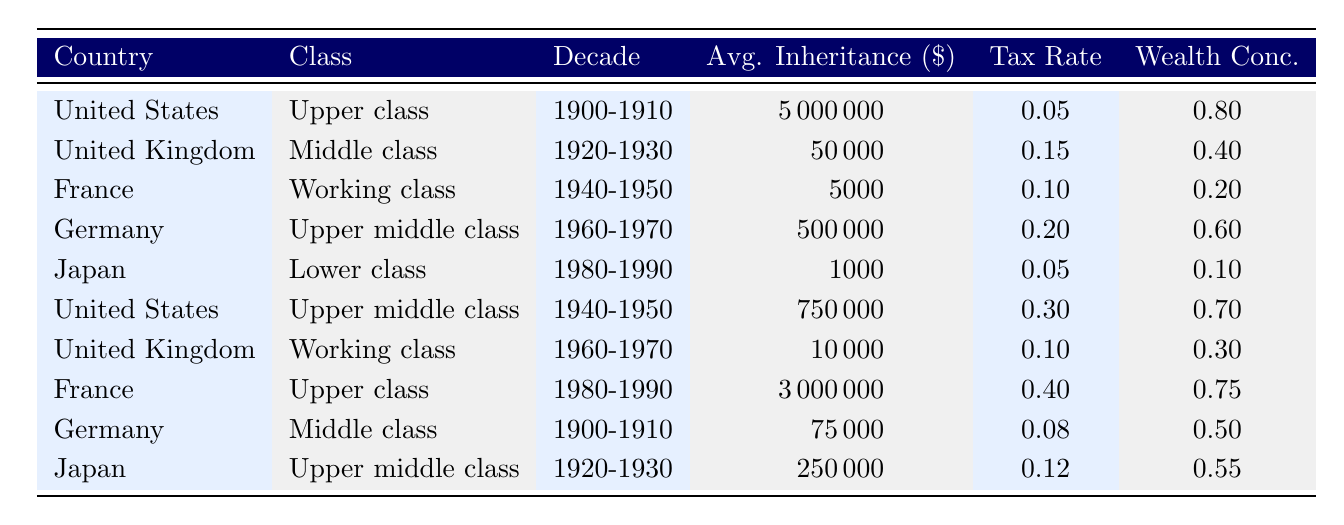What is the average inheritance value for the upper class in the United States during 1900-1910? According to the table, the average inheritance value for the upper class in the United States during 1900-1910 is listed as 5,000,000.
Answer: 5,000,000 What was the inheritance tax rate for the lower class in Japan during 1980-1990? The table states that the inheritance tax rate for the lower class in Japan during 1980-1990 is 0.05.
Answer: 0.05 Which socioeconomic class had the highest average inheritance value in France during 1980-1990? The table indicates that the upper class in France during 1980-1990 had an average inheritance value of 3,000,000, which is higher than any other class listed for that decade in France.
Answer: Upper class Did the working class in the United Kingdom experience a higher average inheritance value in 1960-1970 compared to the working class in France during 1940-1950? The average inheritance value for the working class in the United Kingdom during 1960-1970 is 10,000, while for the working class in France during 1940-1950 it is 5,000. Since 10,000 is greater than 5,000, the statement is true.
Answer: Yes What is the wealth concentration for the upper middle class in Japan during 1920-1930 and how does it compare to the wealth concentration of the lower class in Japan during 1980-1990? The table shows that the upper middle class in Japan during 1920-1930 has a wealth concentration of 0.55, while the lower class in Japan during 1980-1990 has a wealth concentration of 0.1. Therefore, 0.55 is significantly higher than 0.1, indicating greater wealth concentration in the upper middle class.
Answer: 0.55, higher than 0.1 What is the difference in average inheritance values between the upper class in the United States (1900-1910) and the upper middle class in the United States (1940-1950)? The average inheritance for the upper class in the United States (1900-1910) is 5,000,000, while for the upper middle class (1940-1950) it is 750,000. The difference is calculated as 5,000,000 - 750,000 = 4,250,000.
Answer: 4,250,000 How did the inheritance tax rates change for the middle class in Germany from 1900-1910 to 1960-1970? In 1900-1910, the inheritance tax rate for the middle class in Germany was 0.08, and in 1960-1970 it was 0.20. This indicates an increase in the inheritance tax rate over those decades.
Answer: Increased What can be inferred about the trends of average inheritance values across different socioeconomic classes in the United States over the two decades listed? By reviewing the average inheritance values, we note that the upper class had a massive inheritance of 5,000,000 in 1900-1910, while the upper middle class had 750,000 in 1940-1950. This indicates that the upper class continued to retain much larger average inheritances compared to the upper middle class, reflecting wealth preservation in higher classes.
Answer: Upper class retains higher inheritances Which socioeconomic class in Germany had the lowest average inheritance value in the given data? The table shows that the lower class in Japan during 1980-1990 had the lowest average inheritance value listed at 1,000, lower than any other class in Germany.
Answer: Lower class in Japan, 1,000 